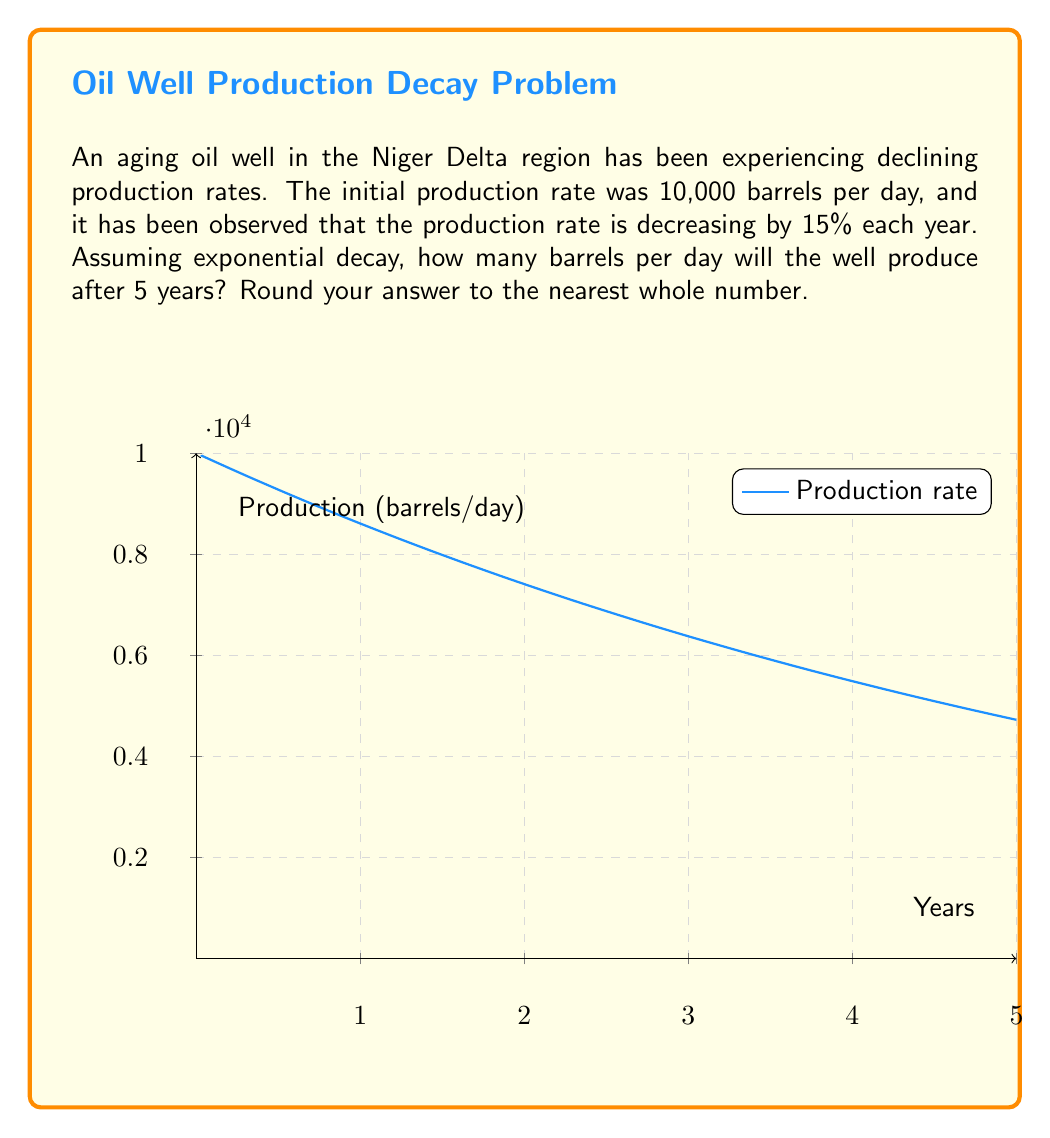Provide a solution to this math problem. Let's approach this problem step-by-step using the exponential decay function:

1) The general form of an exponential decay function is:
   $$ P(t) = P_0 e^{-kt} $$
   where:
   $P(t)$ is the production rate at time $t$
   $P_0$ is the initial production rate
   $k$ is the decay constant
   $t$ is the time in years

2) We know:
   $P_0 = 10,000$ barrels/day
   The rate decreases by 15% per year, so $k = 0.15$
   We want to find $P(5)$, so $t = 5$ years

3) Substituting these values into the equation:
   $$ P(5) = 10,000 e^{-0.15 * 5} $$

4) Simplify the exponent:
   $$ P(5) = 10,000 e^{-0.75} $$

5) Calculate using a scientific calculator or computer:
   $$ P(5) = 10,000 * 0.4723665527 $$
   $$ P(5) = 4723.665527 $$

6) Rounding to the nearest whole number:
   $$ P(5) \approx 4724 $$

Therefore, after 5 years, the well will produce approximately 4,724 barrels per day.
Answer: 4,724 barrels per day 